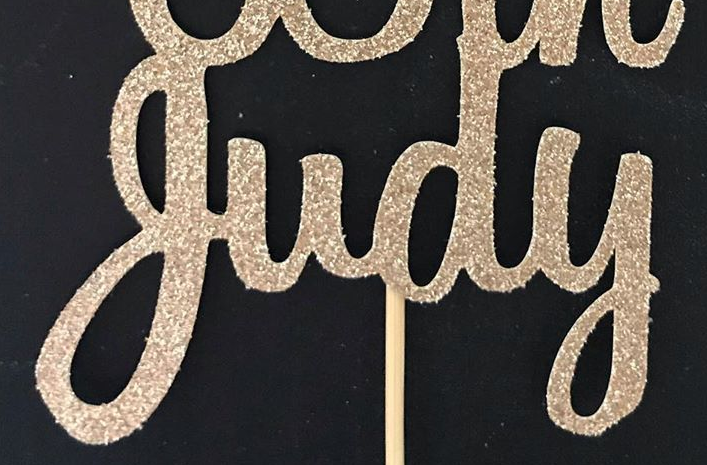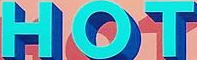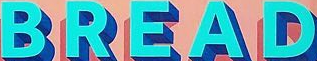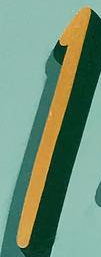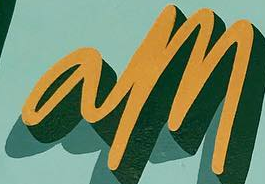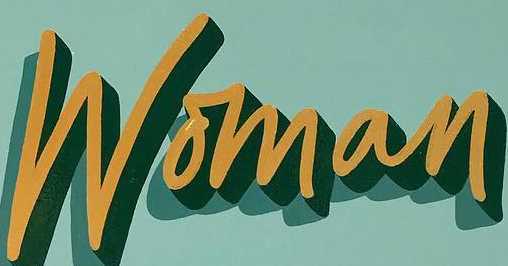What words are shown in these images in order, separated by a semicolon? judy; HOT; BREAD; I; am; Woman 